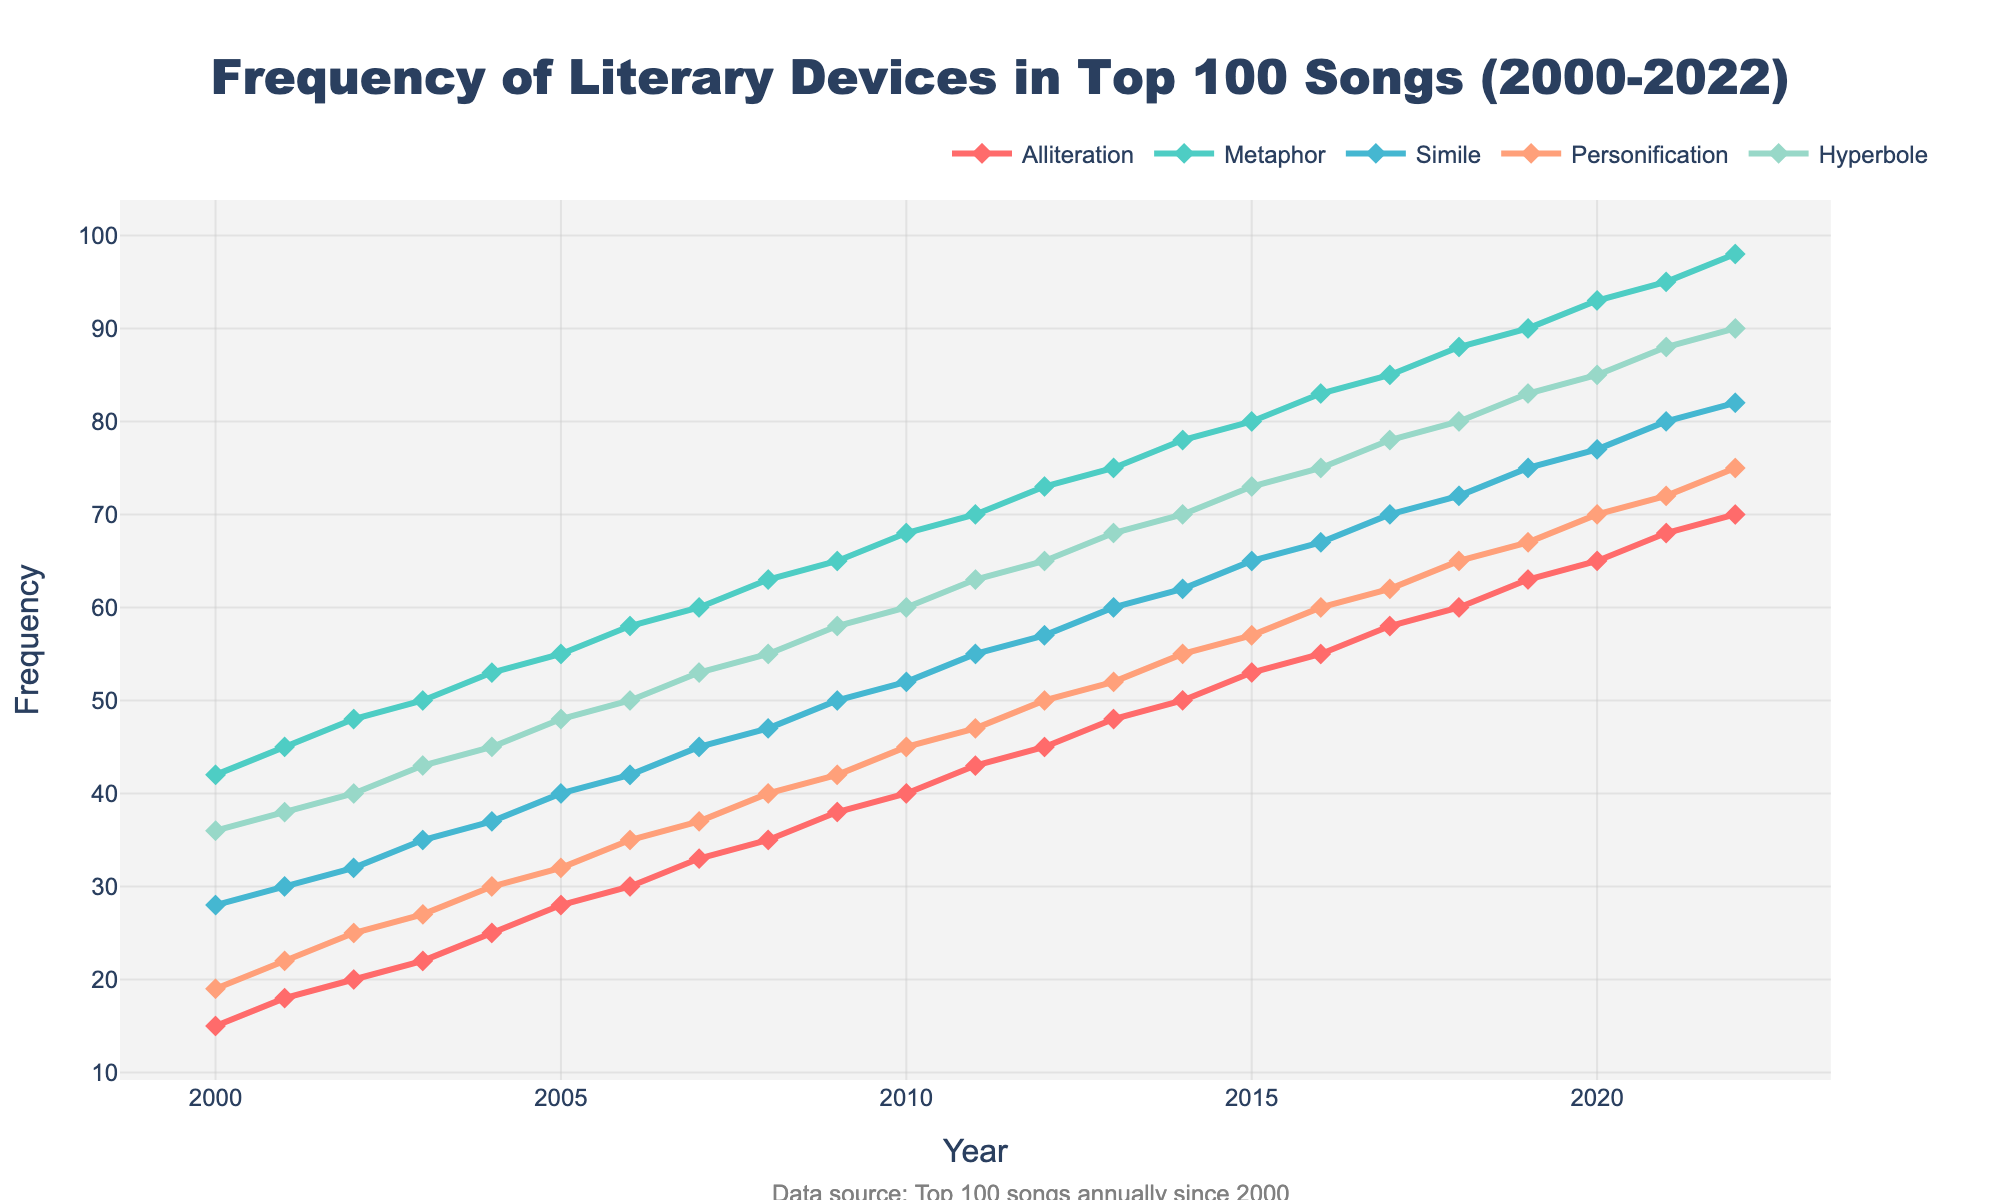What is the overall trend in the usage of metaphors from 2000 to 2022? The line for metaphors consistently rises, indicating a steady increase in usage over the years. The frequency starts at 42 in 2000 and reaches 98 in 2022.
Answer: Steady increase Which literary device saw the highest frequency in 2022? By looking at the line chart, we identify that the metaphors hit the highest point at 98 in 2022.
Answer: Metaphor Between which two years did the frequency of personification increase the most? Find the years where the personification line shows the steepest incline. The largest rise occurs between 2001 and 2002, with an increase from 22 to 25, and between 2014 and 2015, with an increase from 55 to 57.
Answer: 2014 and 2015 How many times did the frequency of alliteration increase from 2000 to 2022? The frequency of alliteration starts at 15 in 2000 and ends at 70 in 2022. Increase can be calculated: 70 - 15 = 55.
Answer: 55 times Which year had the lowest frequency of hyperbole, and what was the value? By observing the bottom-most point in the hyperbole line, we find that the lowest value occurs in 2000 with a frequency of 36.
Answer: 2000, 36 Compare the frequencies of simile and hyperbole in 2010. Which is higher and by how much? In 2010, the frequency of simile is 52 while that of hyperbole is 60. Calculating the difference: 60 - 52 = 8.
Answer: Hyperbole by 8 What is the average frequency of all literary devices in 2005? Sum the frequencies in 2005: 28 + 55 + 40 + 32 + 48 = 203. Divide this sum by the number of devices (5): 203 / 5 = 40.6.
Answer: 40.6 Which literary device has shown the most consistent growth pattern? By analyzing the smoothness of the line trends, we observe that the metaphor line shows the most stable and consistent upward growth with no declines or abnormally steep rises.
Answer: Metaphor How does the frequency of simile change from 2016 to 2017? The frequency of simile in 2016 is 67 and in 2017 it is 70. The change can be calculated: 70 - 67 = 3.
Answer: Increases by 3 What is the cumulative frequency of personification from 2010 to 2020? Sum the yearly frequencies from 2010 to 2020: 45 + 47 + 50 + 52 + 55 + 57 + 60 + 62 + 65 + 67 + 70 = 622.
Answer: 622 